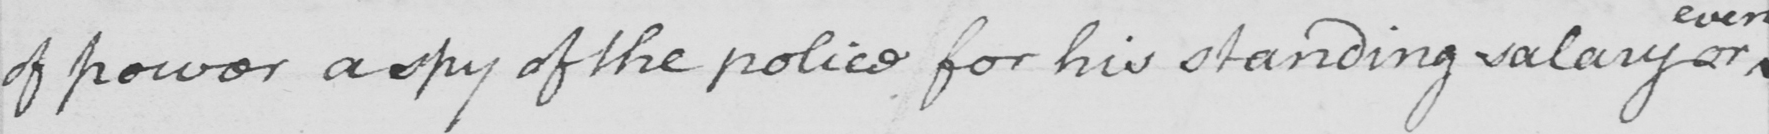Transcribe the text shown in this historical manuscript line. of power a spy of the police for his standing salary or 